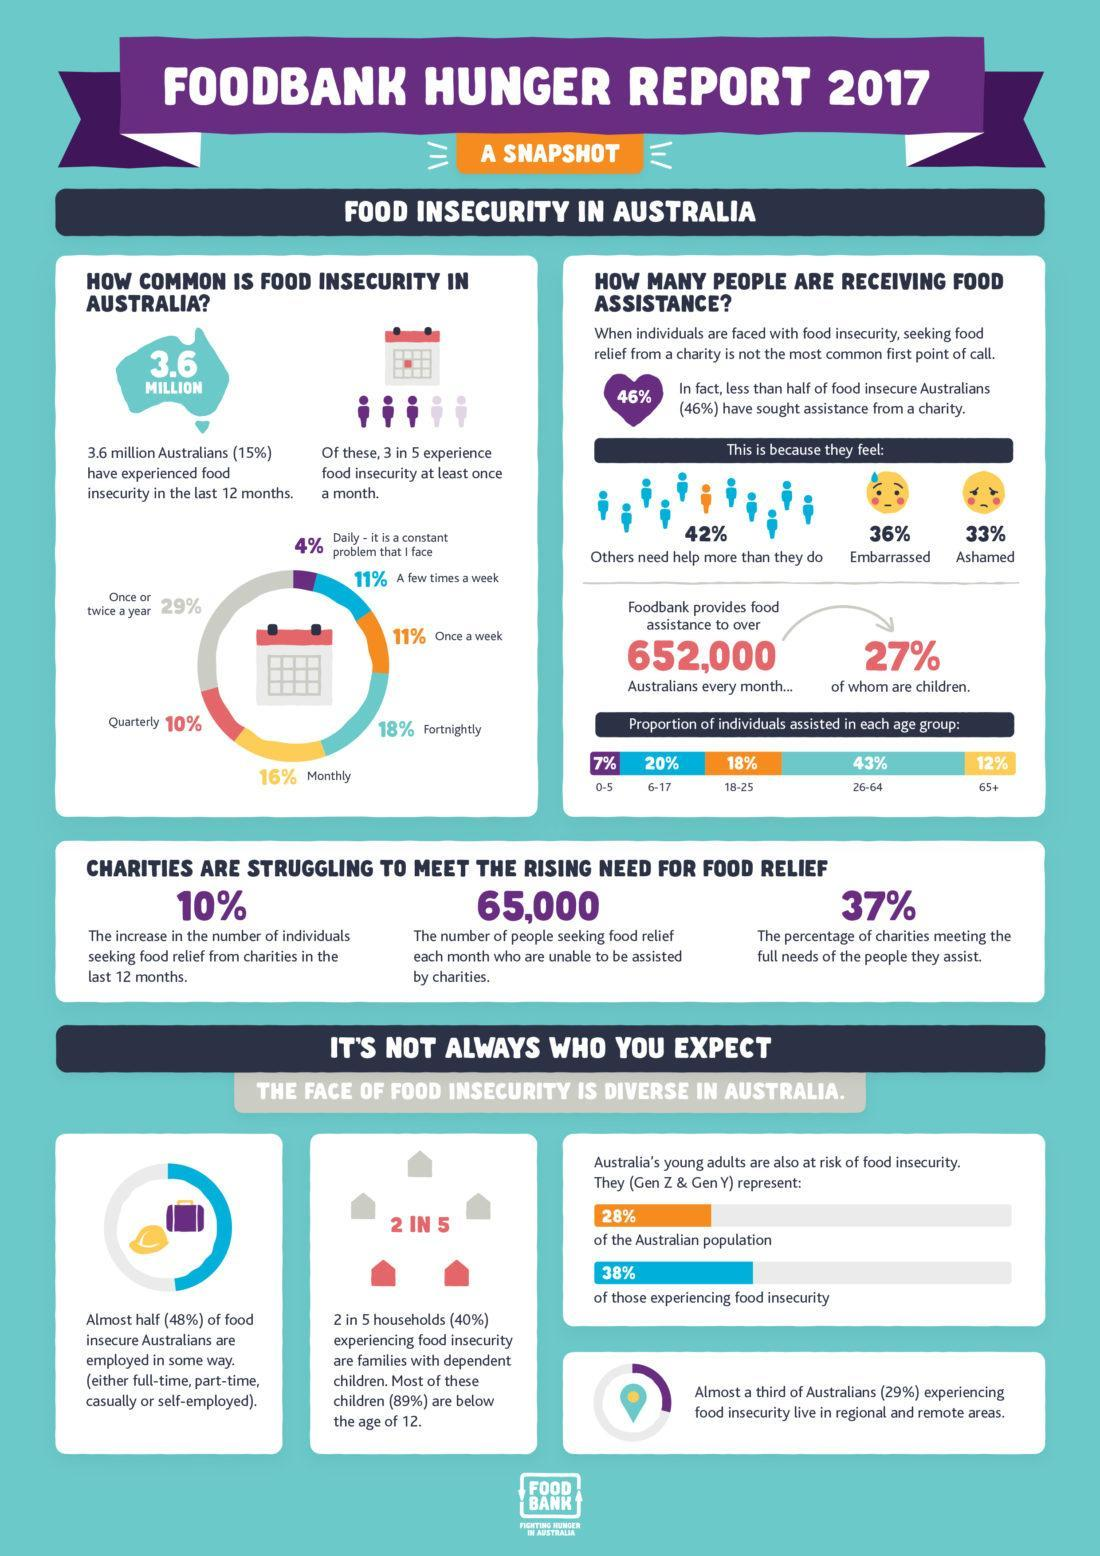What percentage of charities are meeting the full needs of the people they assist?
Answer the question with a short phrase. 37% What percentage of food insecure Australians embarrassed about seeking assistance from a charity? 36% What percentage of food insecure Australians are ashamed of seeking assistance from a charity? 33% 